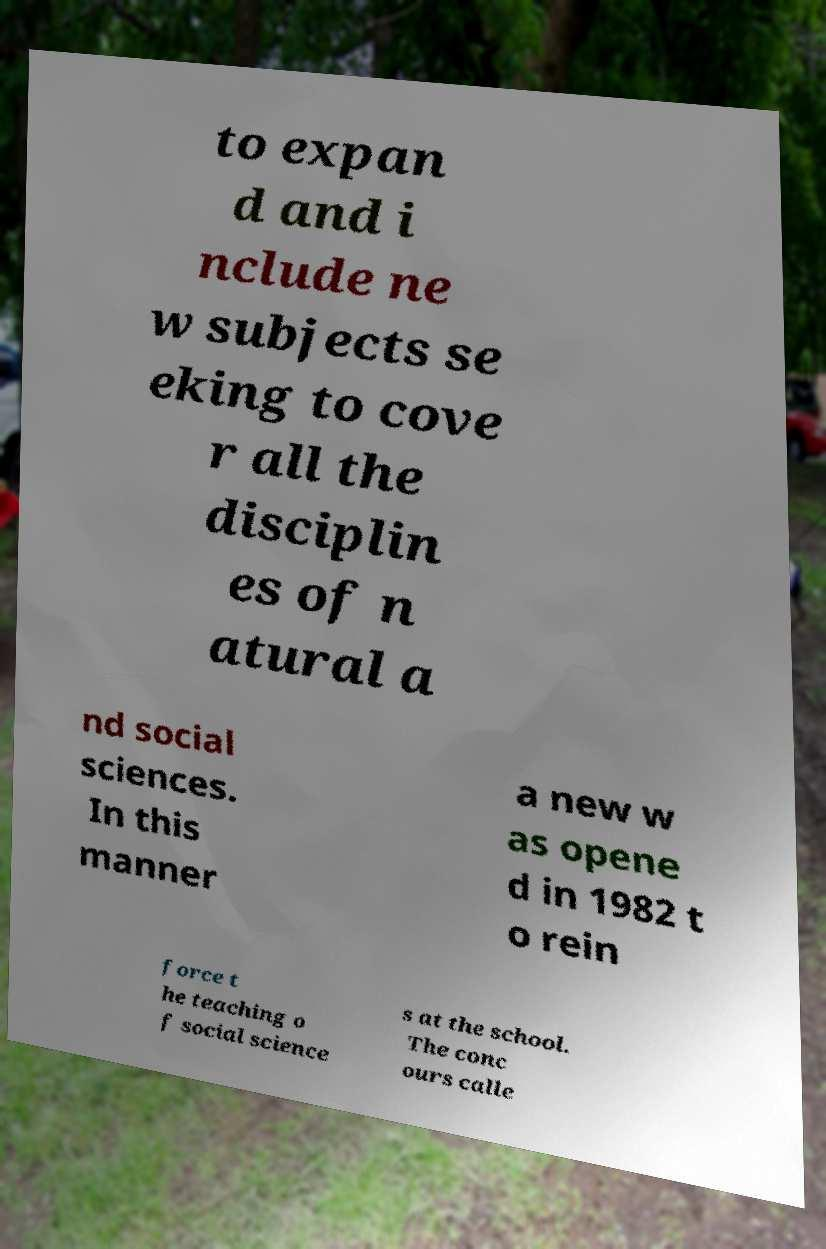I need the written content from this picture converted into text. Can you do that? to expan d and i nclude ne w subjects se eking to cove r all the disciplin es of n atural a nd social sciences. In this manner a new w as opene d in 1982 t o rein force t he teaching o f social science s at the school. The conc ours calle 